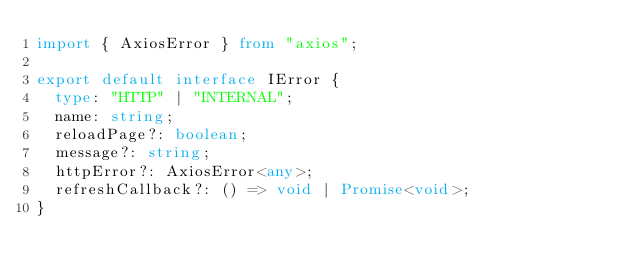<code> <loc_0><loc_0><loc_500><loc_500><_TypeScript_>import { AxiosError } from "axios";

export default interface IError {
  type: "HTTP" | "INTERNAL";
  name: string;
  reloadPage?: boolean;
  message?: string;
  httpError?: AxiosError<any>;
  refreshCallback?: () => void | Promise<void>;
}
</code> 